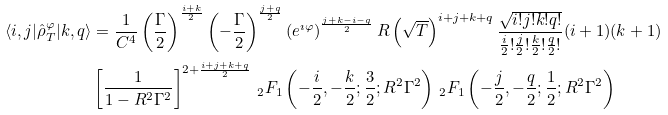Convert formula to latex. <formula><loc_0><loc_0><loc_500><loc_500>\langle i , j | \hat { \rho } ^ { \varphi } _ { T } | k , q \rangle & = \frac { 1 } { C ^ { 4 } } \left ( \frac { \Gamma } { 2 } \right ) ^ { \frac { i + k } { 2 } } \left ( - \frac { \Gamma } { 2 } \right ) ^ { \frac { j + q } { 2 } } \left ( e ^ { \imath \varphi } \right ) ^ { \frac { j + k - i - q } { 2 } } R \left ( \sqrt { T } \right ) ^ { i + j + k + q } \frac { \sqrt { i ! j ! k ! q ! } } { \frac { i } { 2 } ! \frac { j } { 2 } ! \frac { k } { 2 } ! \frac { q } { 2 } ! } ( i + 1 ) ( k + 1 ) \\ & \left [ \frac { 1 } { 1 - R ^ { 2 } \Gamma ^ { 2 } } \right ] ^ { 2 + \frac { i + j + k + q } { 2 } } \, _ { 2 } F _ { 1 } \left ( - \frac { i } { 2 } , - \frac { k } { 2 } ; \frac { 3 } { 2 } ; R ^ { 2 } \Gamma ^ { 2 } \right ) \, _ { 2 } F _ { 1 } \left ( - \frac { j } { 2 } , - \frac { q } { 2 } ; \frac { 1 } { 2 } ; R ^ { 2 } \Gamma ^ { 2 } \right )</formula> 